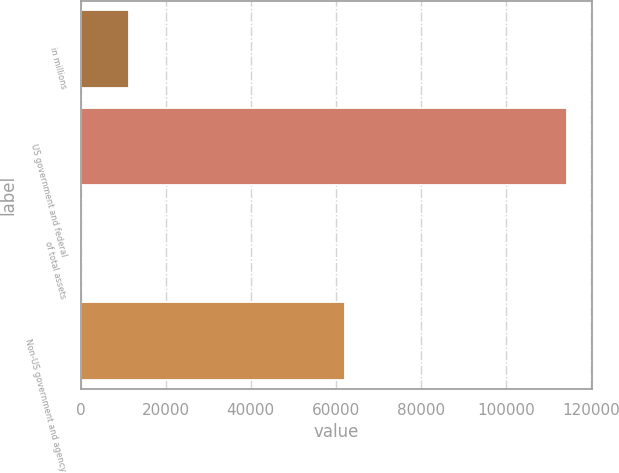Convert chart to OTSL. <chart><loc_0><loc_0><loc_500><loc_500><bar_chart><fcel>in millions<fcel>US government and federal<fcel>of total assets<fcel>Non-US government and agency<nl><fcel>11452.8<fcel>114418<fcel>12.2<fcel>62252<nl></chart> 